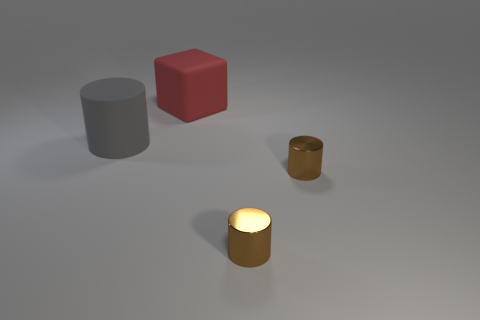Subtract all metallic cylinders. How many cylinders are left? 1 Add 1 gray matte things. How many objects exist? 5 Subtract all gray cylinders. How many cylinders are left? 2 Subtract all blocks. How many objects are left? 3 Subtract all blue cylinders. Subtract all gray spheres. How many cylinders are left? 3 Subtract all brown cylinders. How many yellow cubes are left? 0 Subtract all big objects. Subtract all rubber blocks. How many objects are left? 1 Add 1 small metallic things. How many small metallic things are left? 3 Add 4 cylinders. How many cylinders exist? 7 Subtract 0 brown spheres. How many objects are left? 4 